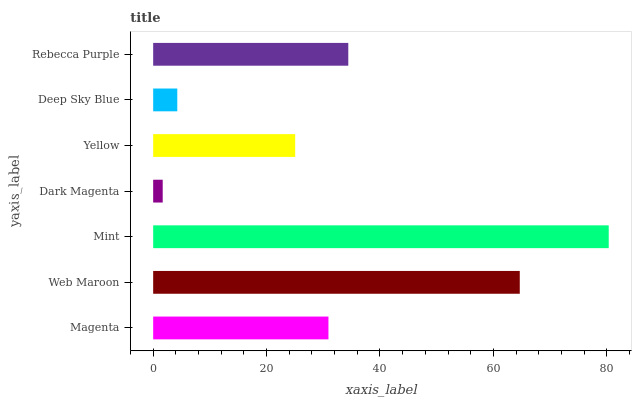Is Dark Magenta the minimum?
Answer yes or no. Yes. Is Mint the maximum?
Answer yes or no. Yes. Is Web Maroon the minimum?
Answer yes or no. No. Is Web Maroon the maximum?
Answer yes or no. No. Is Web Maroon greater than Magenta?
Answer yes or no. Yes. Is Magenta less than Web Maroon?
Answer yes or no. Yes. Is Magenta greater than Web Maroon?
Answer yes or no. No. Is Web Maroon less than Magenta?
Answer yes or no. No. Is Magenta the high median?
Answer yes or no. Yes. Is Magenta the low median?
Answer yes or no. Yes. Is Rebecca Purple the high median?
Answer yes or no. No. Is Yellow the low median?
Answer yes or no. No. 